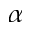<formula> <loc_0><loc_0><loc_500><loc_500>\alpha</formula> 